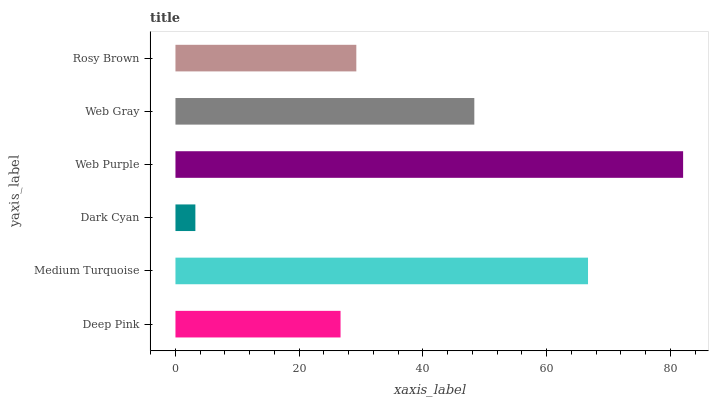Is Dark Cyan the minimum?
Answer yes or no. Yes. Is Web Purple the maximum?
Answer yes or no. Yes. Is Medium Turquoise the minimum?
Answer yes or no. No. Is Medium Turquoise the maximum?
Answer yes or no. No. Is Medium Turquoise greater than Deep Pink?
Answer yes or no. Yes. Is Deep Pink less than Medium Turquoise?
Answer yes or no. Yes. Is Deep Pink greater than Medium Turquoise?
Answer yes or no. No. Is Medium Turquoise less than Deep Pink?
Answer yes or no. No. Is Web Gray the high median?
Answer yes or no. Yes. Is Rosy Brown the low median?
Answer yes or no. Yes. Is Web Purple the high median?
Answer yes or no. No. Is Deep Pink the low median?
Answer yes or no. No. 